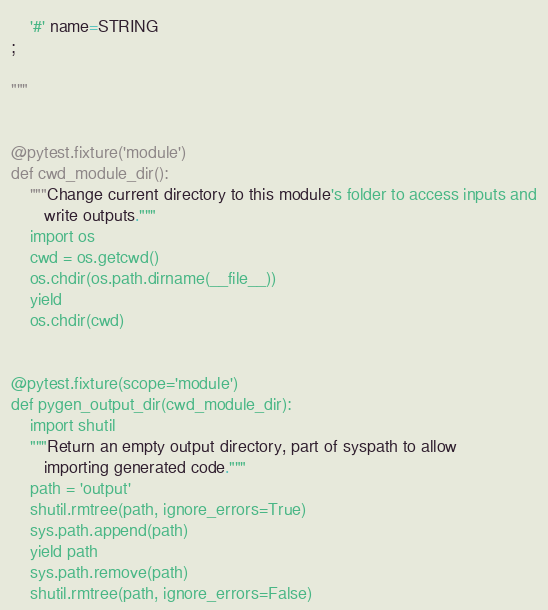Convert code to text. <code><loc_0><loc_0><loc_500><loc_500><_Python_>    '#' name=STRING
;

"""


@pytest.fixture('module')
def cwd_module_dir():
    """Change current directory to this module's folder to access inputs and
       write outputs."""
    import os
    cwd = os.getcwd()
    os.chdir(os.path.dirname(__file__))
    yield
    os.chdir(cwd)


@pytest.fixture(scope='module')
def pygen_output_dir(cwd_module_dir):
    import shutil
    """Return an empty output directory, part of syspath to allow
       importing generated code."""
    path = 'output'
    shutil.rmtree(path, ignore_errors=True)
    sys.path.append(path)
    yield path
    sys.path.remove(path)
    shutil.rmtree(path, ignore_errors=False)

</code> 